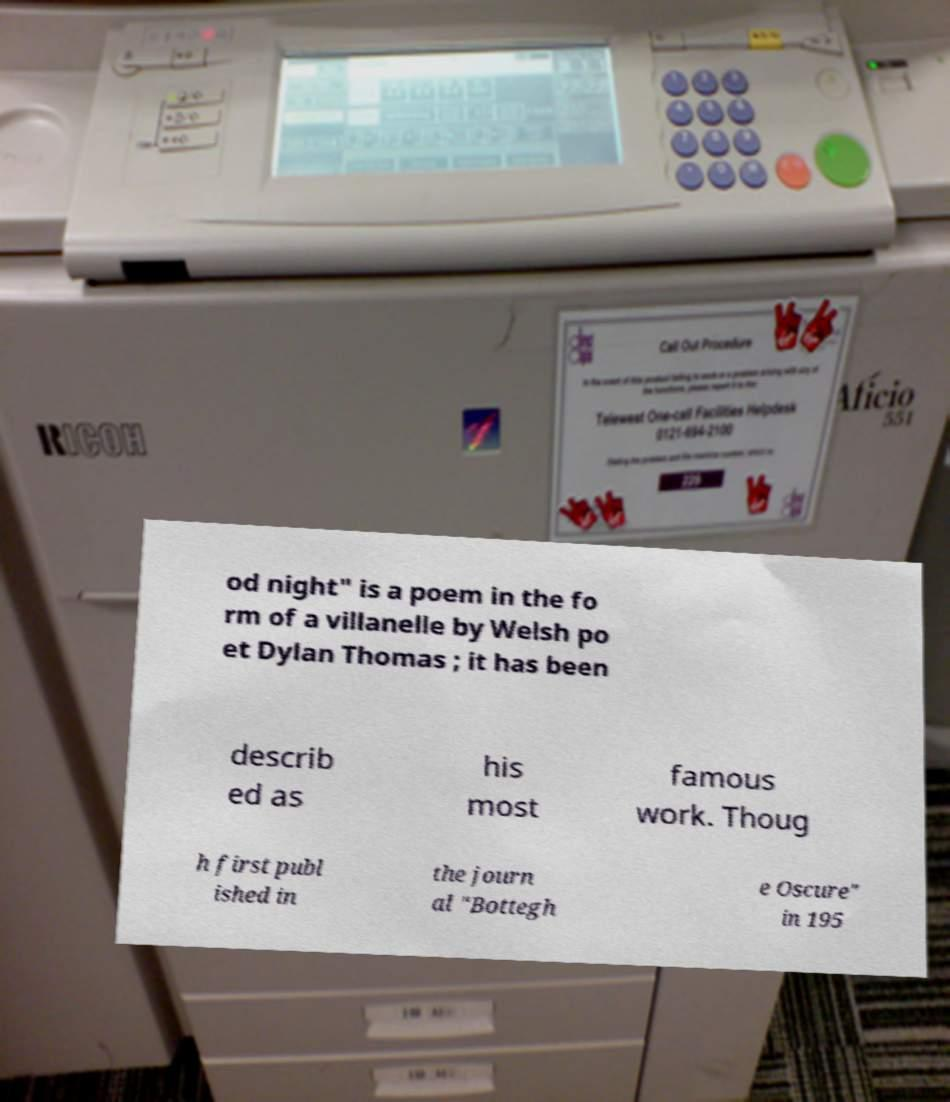Please read and relay the text visible in this image. What does it say? od night" is a poem in the fo rm of a villanelle by Welsh po et Dylan Thomas ; it has been describ ed as his most famous work. Thoug h first publ ished in the journ al "Bottegh e Oscure" in 195 